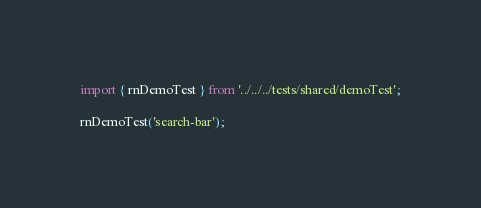Convert code to text. <code><loc_0><loc_0><loc_500><loc_500><_JavaScript_>import { rnDemoTest } from '../../../tests/shared/demoTest';

rnDemoTest('search-bar');
</code> 